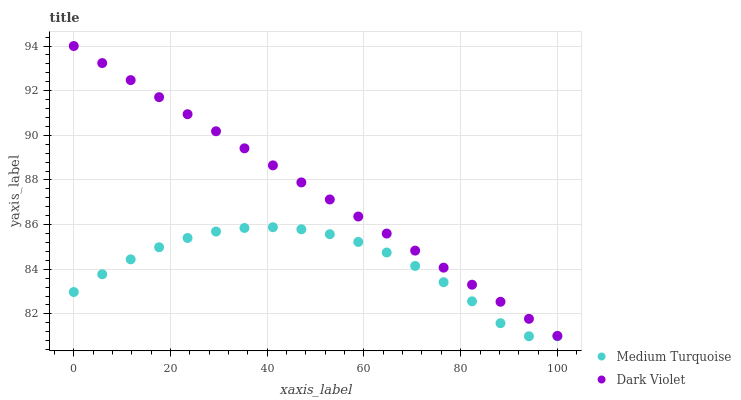Does Medium Turquoise have the minimum area under the curve?
Answer yes or no. Yes. Does Dark Violet have the maximum area under the curve?
Answer yes or no. Yes. Does Medium Turquoise have the maximum area under the curve?
Answer yes or no. No. Is Dark Violet the smoothest?
Answer yes or no. Yes. Is Medium Turquoise the roughest?
Answer yes or no. Yes. Is Medium Turquoise the smoothest?
Answer yes or no. No. Does Medium Turquoise have the lowest value?
Answer yes or no. Yes. Does Dark Violet have the highest value?
Answer yes or no. Yes. Does Medium Turquoise have the highest value?
Answer yes or no. No. Is Medium Turquoise less than Dark Violet?
Answer yes or no. Yes. Is Dark Violet greater than Medium Turquoise?
Answer yes or no. Yes. Does Medium Turquoise intersect Dark Violet?
Answer yes or no. No. 